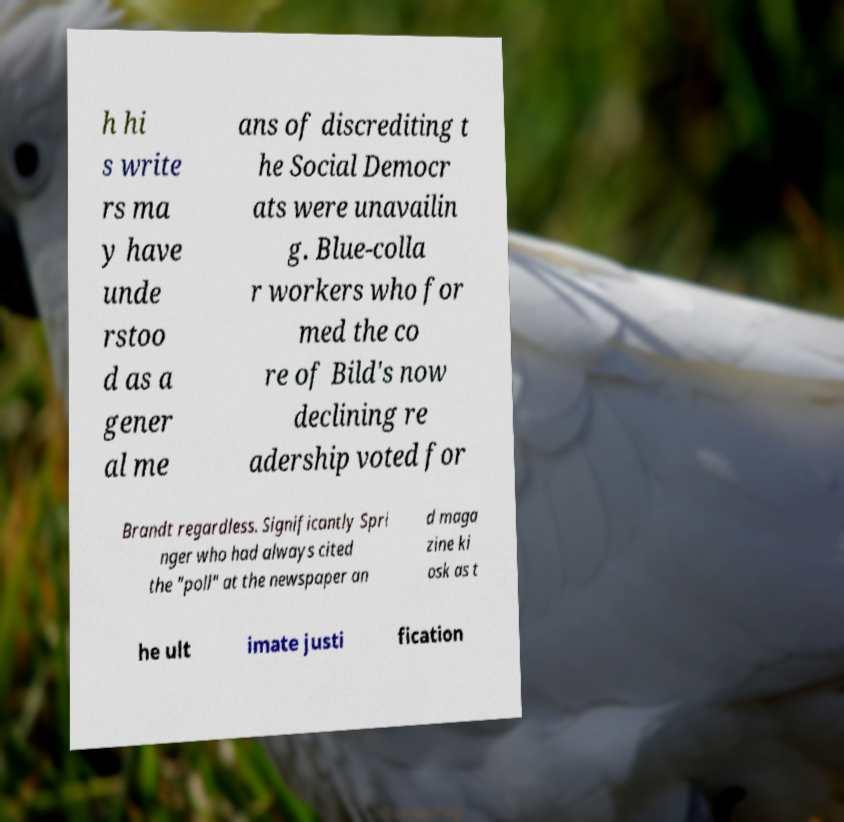For documentation purposes, I need the text within this image transcribed. Could you provide that? h hi s write rs ma y have unde rstoo d as a gener al me ans of discrediting t he Social Democr ats were unavailin g. Blue-colla r workers who for med the co re of Bild's now declining re adership voted for Brandt regardless. Significantly Spri nger who had always cited the "poll" at the newspaper an d maga zine ki osk as t he ult imate justi fication 